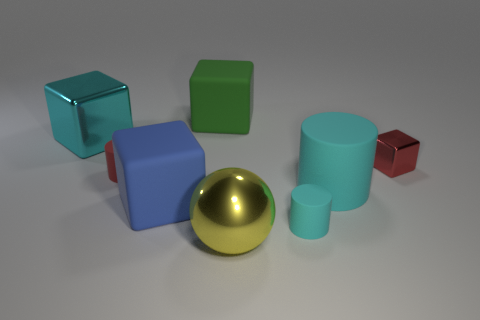What material is the block that is the same color as the large cylinder?
Your answer should be very brief. Metal. Do the large metallic cube and the big rubber cylinder have the same color?
Make the answer very short. Yes. Are there more metallic cubes that are on the right side of the small cyan cylinder than large green blocks on the right side of the red metal block?
Keep it short and to the point. Yes. There is a small thing that is behind the red matte cylinder; what color is it?
Offer a terse response. Red. Are there any big cyan metal objects of the same shape as the large green thing?
Provide a short and direct response. Yes. What number of cyan things are cylinders or large cylinders?
Your answer should be very brief. 2. Is there a red shiny block of the same size as the blue rubber thing?
Keep it short and to the point. No. How many red things are there?
Your answer should be compact. 2. How many large things are either green shiny cubes or red metallic cubes?
Make the answer very short. 0. There is a large thing that is left of the cylinder that is left of the large matte object that is behind the cyan metal cube; what is its color?
Provide a short and direct response. Cyan. 